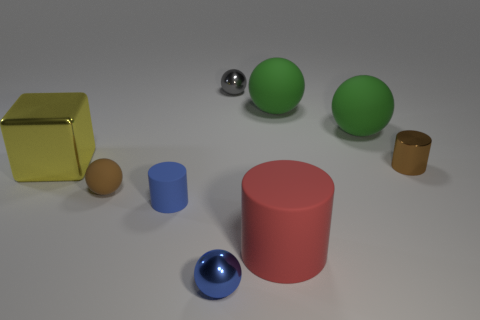Can you describe the arrangement of objects and their colors in the image? Certainly, the image displays a variety of objects arranged against a uniform background. There's a large yellow shiny cube, a large red cylinder, and two green spheres in the center. To the left, there is a small brown rubber-looking object next to a smaller blue cylinder, while a metallic sphere rests in the middle right. A tiny brown egg-shaped object sits in the front. 